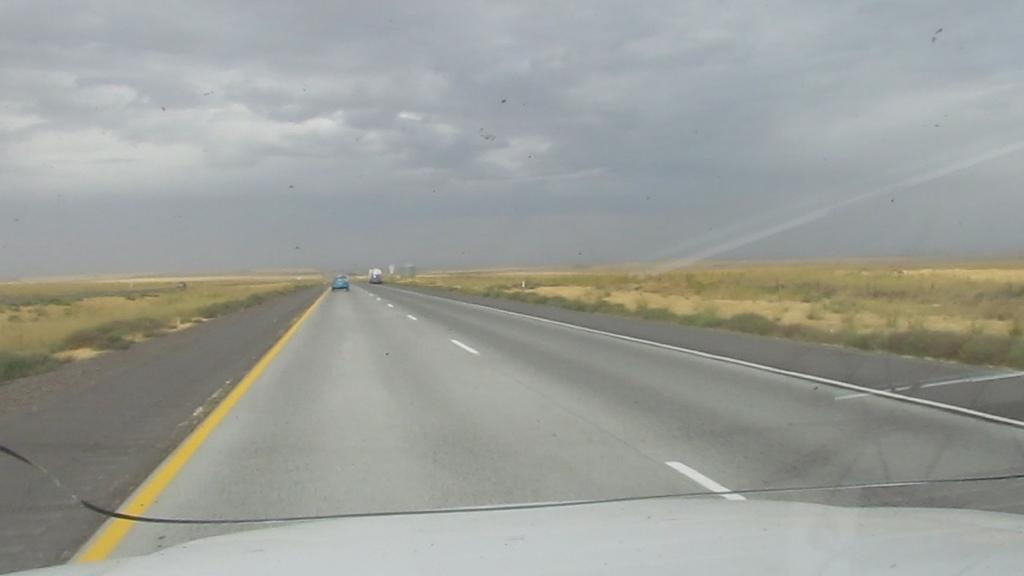What can be seen in the sky in the image? The sky with clouds is visible in the image. What type of vehicles are on the road in the image? There are motor vehicles on the road in the image. What type of vegetation is present on either side of the road? Grass is present on either side of the road. What type of berry is being discussed by the clouds in the image? There is no berry being discussed by the clouds in the image, as clouds are not capable of having discussions. 